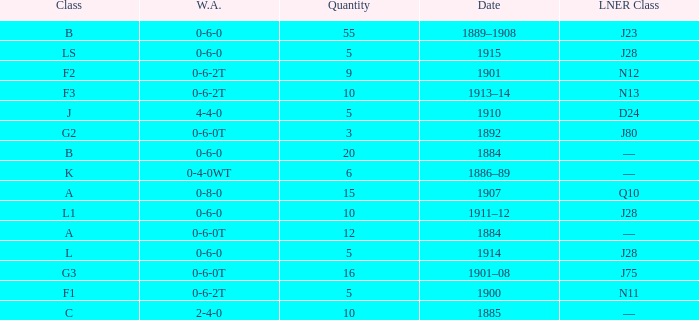What WA has a LNER Class of n13 and 10? 0-6-2T. 